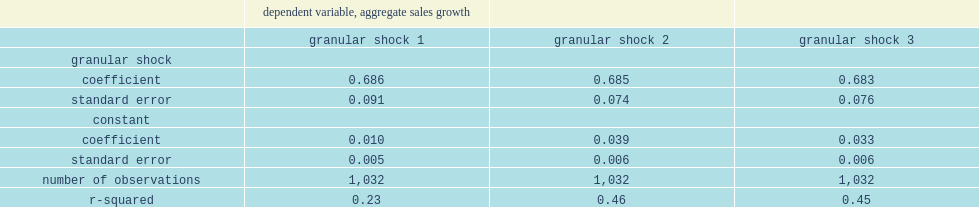What is the percentage of the annual variation in industry sales growth explained by the granular shock measure gs1? 0.23. What is the percentage of the annual variation in industry sales growth explained by the granular shock measure gs2? 0.46. 